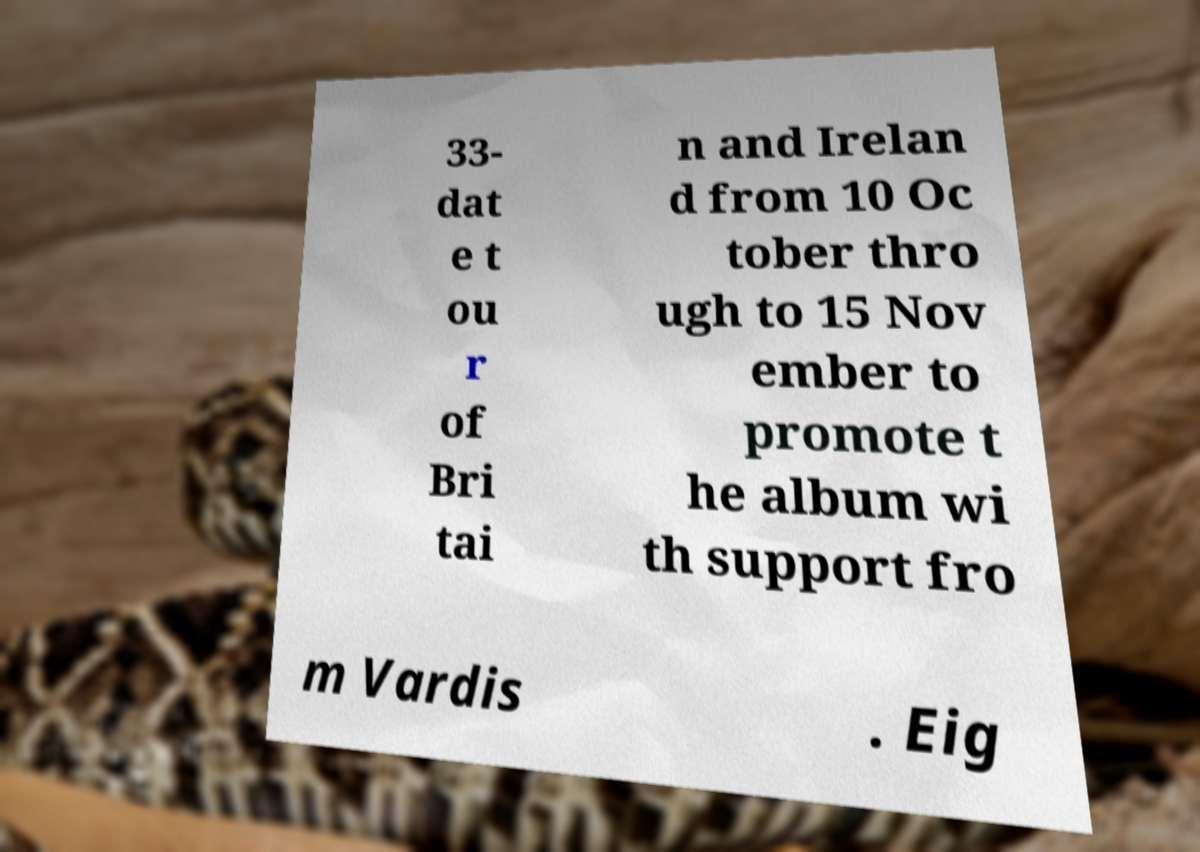Please read and relay the text visible in this image. What does it say? 33- dat e t ou r of Bri tai n and Irelan d from 10 Oc tober thro ugh to 15 Nov ember to promote t he album wi th support fro m Vardis . Eig 